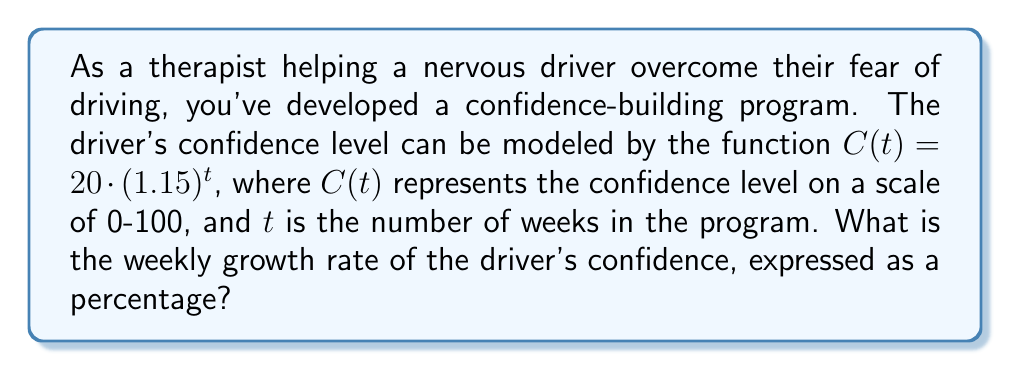Can you answer this question? To determine the weekly growth rate of the driver's confidence, we need to analyze the given exponential function:

$C(t) = 20 \cdot (1.15)^t$

In an exponential function of the form $f(t) = a \cdot b^t$, the base $b$ represents the growth factor for each unit of $t$. In this case, $b = 1.15$.

To convert the growth factor to a percentage growth rate, we subtract 1 from the growth factor and multiply by 100:

Growth rate = $(b - 1) \times 100\%$
Growth rate = $(1.15 - 1) \times 100\%$
Growth rate = $0.15 \times 100\%$
Growth rate = $15\%$

This means that each week, the driver's confidence increases by 15% compared to the previous week.

We can verify this by looking at the change between any two consecutive weeks:

Week 1: $C(1) = 20 \cdot (1.15)^1 = 23$
Week 2: $C(2) = 20 \cdot (1.15)^2 = 26.45$

The ratio of these values is:
$\frac{C(2)}{C(1)} = \frac{26.45}{23} \approx 1.15$

This confirms that the confidence level increases by a factor of 1.15, or 15%, each week.
Answer: The weekly growth rate of the driver's confidence is 15%. 